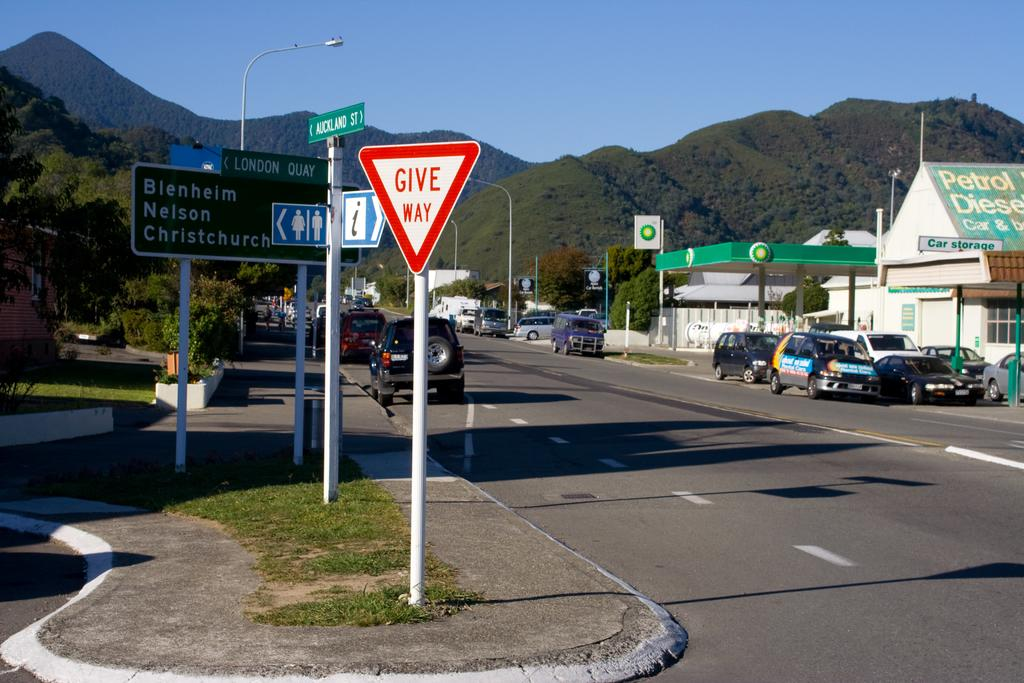<image>
Provide a brief description of the given image. the words give way are on the red and white sign 